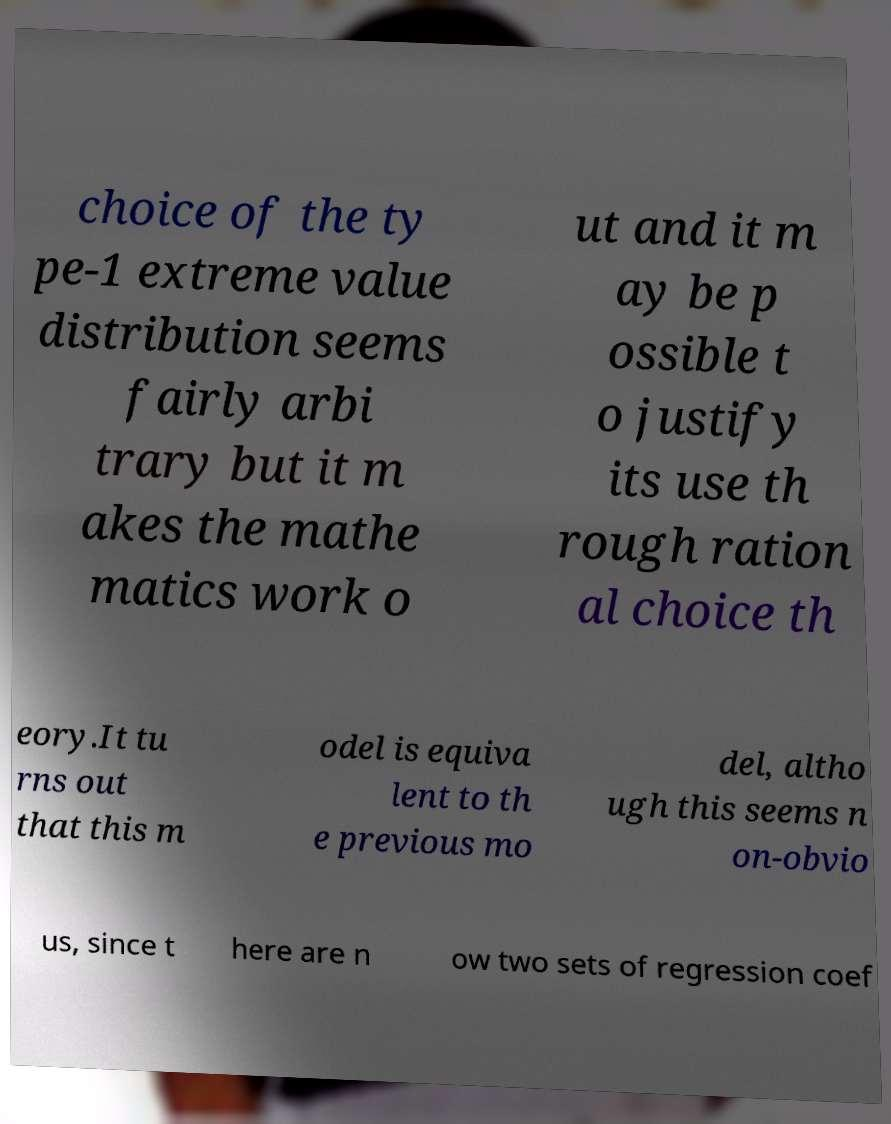Can you accurately transcribe the text from the provided image for me? choice of the ty pe-1 extreme value distribution seems fairly arbi trary but it m akes the mathe matics work o ut and it m ay be p ossible t o justify its use th rough ration al choice th eory.It tu rns out that this m odel is equiva lent to th e previous mo del, altho ugh this seems n on-obvio us, since t here are n ow two sets of regression coef 